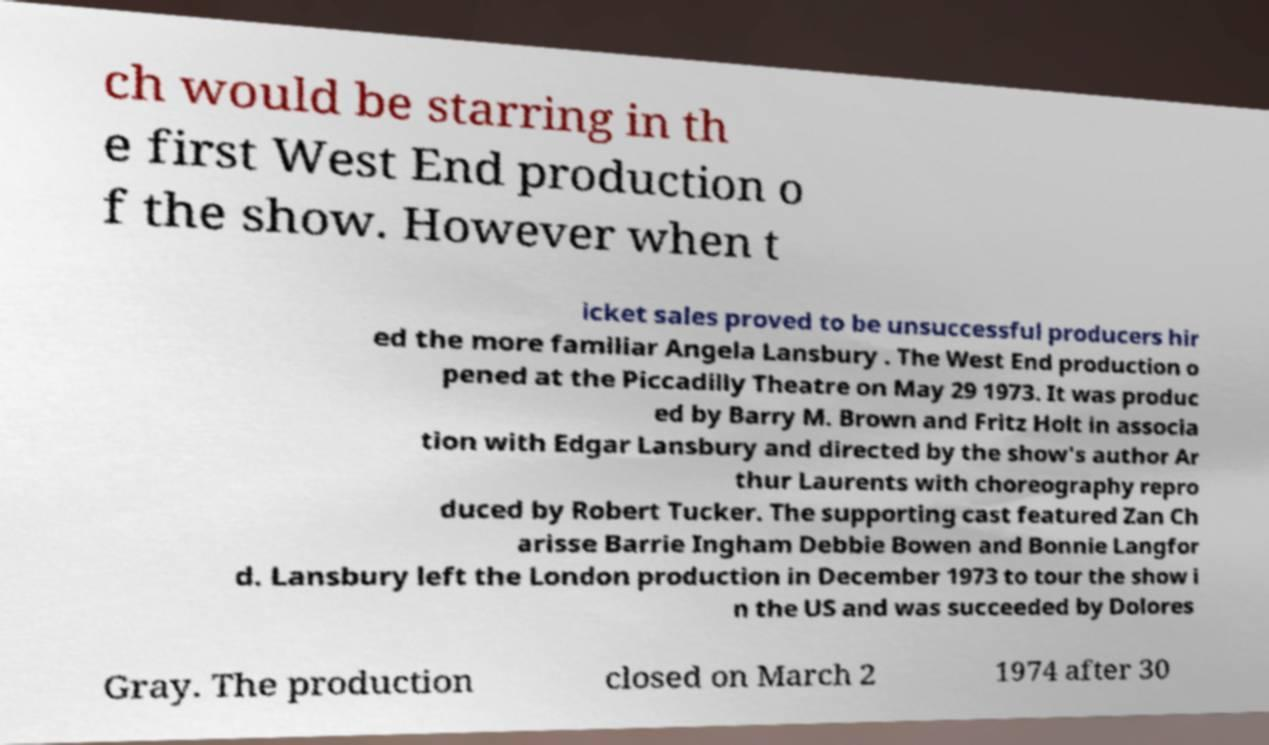Can you accurately transcribe the text from the provided image for me? ch would be starring in th e first West End production o f the show. However when t icket sales proved to be unsuccessful producers hir ed the more familiar Angela Lansbury . The West End production o pened at the Piccadilly Theatre on May 29 1973. It was produc ed by Barry M. Brown and Fritz Holt in associa tion with Edgar Lansbury and directed by the show's author Ar thur Laurents with choreography repro duced by Robert Tucker. The supporting cast featured Zan Ch arisse Barrie Ingham Debbie Bowen and Bonnie Langfor d. Lansbury left the London production in December 1973 to tour the show i n the US and was succeeded by Dolores Gray. The production closed on March 2 1974 after 30 